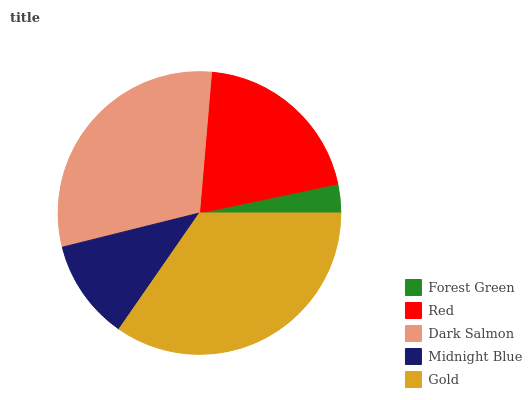Is Forest Green the minimum?
Answer yes or no. Yes. Is Gold the maximum?
Answer yes or no. Yes. Is Red the minimum?
Answer yes or no. No. Is Red the maximum?
Answer yes or no. No. Is Red greater than Forest Green?
Answer yes or no. Yes. Is Forest Green less than Red?
Answer yes or no. Yes. Is Forest Green greater than Red?
Answer yes or no. No. Is Red less than Forest Green?
Answer yes or no. No. Is Red the high median?
Answer yes or no. Yes. Is Red the low median?
Answer yes or no. Yes. Is Forest Green the high median?
Answer yes or no. No. Is Gold the low median?
Answer yes or no. No. 